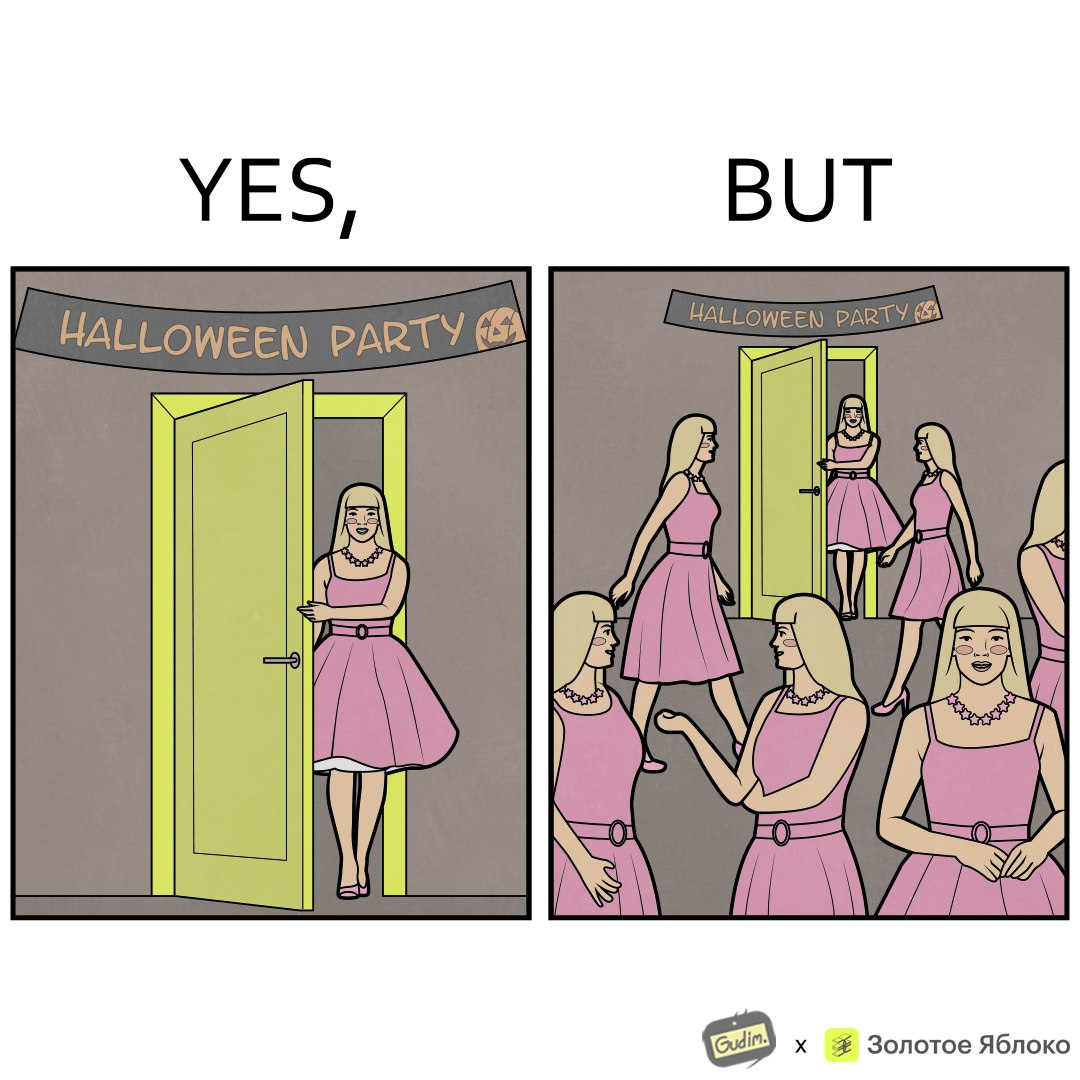Compare the left and right sides of this image. In the left part of the image: A woman entering a Halloween Party wearing a pink top and skirt with a necklace around the neck as costume. In the right part of the image: A person entering a Halloween Party wearing a pink top and skirt along with a necklace around the neck as costume, and others in the room have the same costume. 